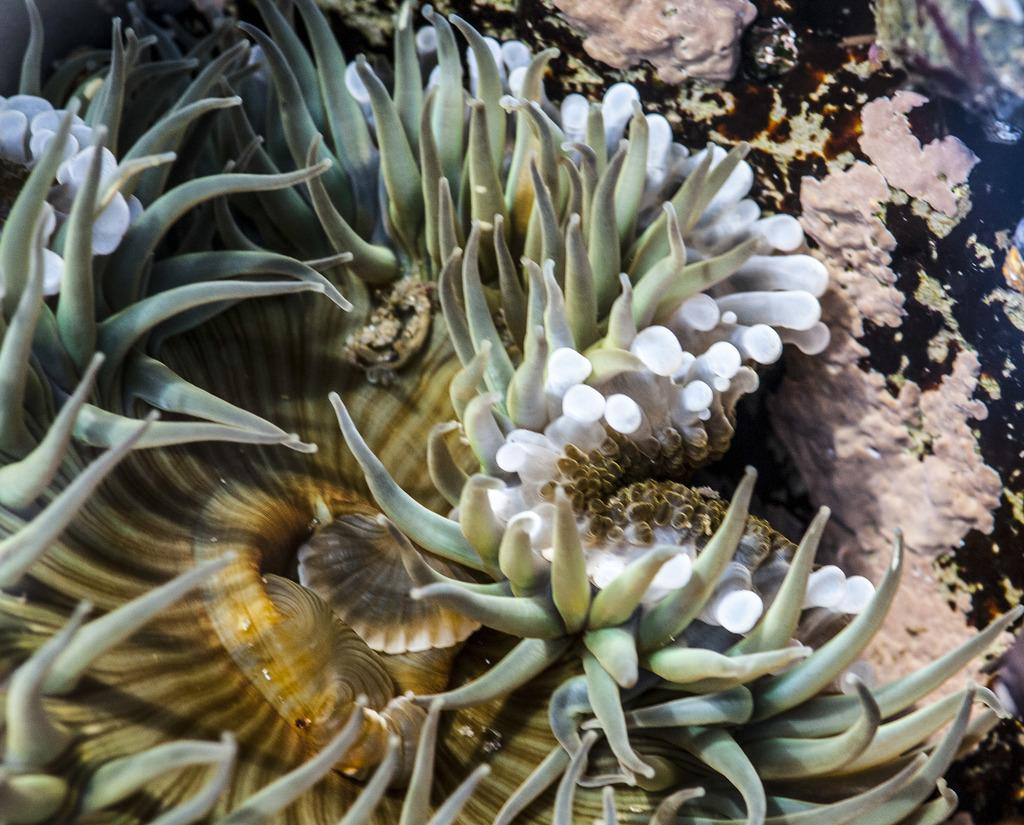What type of plant is the focus of the image? The image is a zoom-in view of an aquatic plant. Can you describe any specific features of the plant? Unfortunately, the image only provides a close-up view of the plant, so it's difficult to describe any specific features. What type of approval does the plant need to grow in the image? The image does not depict the plant's growth or any approval process; it is simply a close-up view of an aquatic plant. 